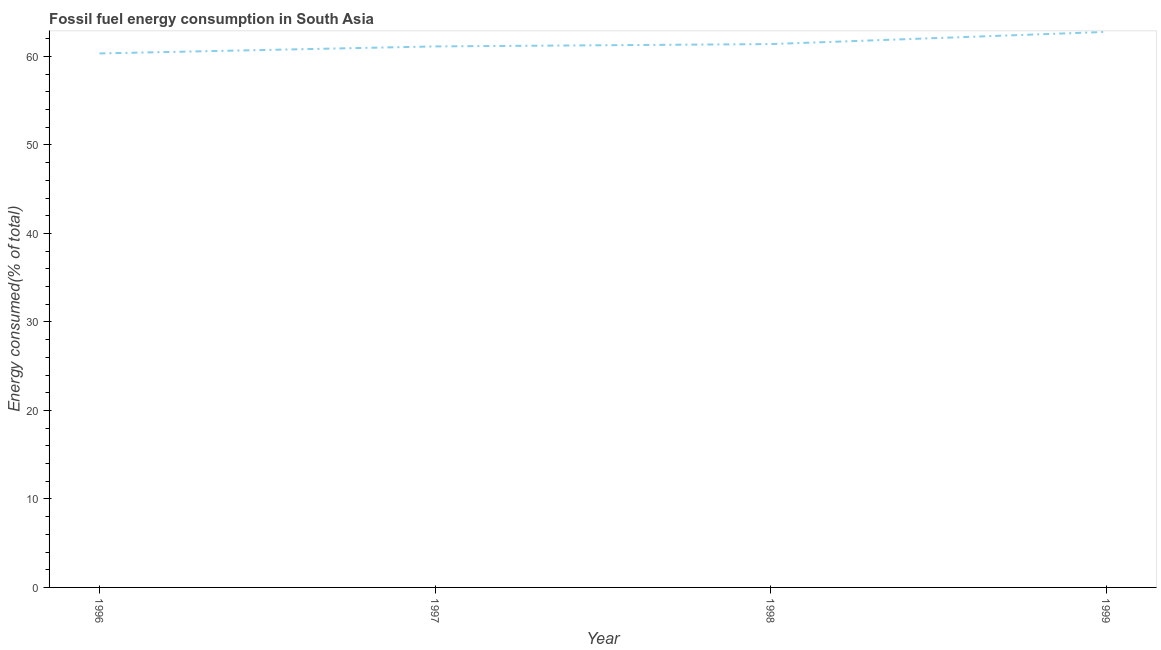What is the fossil fuel energy consumption in 1998?
Provide a succinct answer. 61.4. Across all years, what is the maximum fossil fuel energy consumption?
Give a very brief answer. 62.78. Across all years, what is the minimum fossil fuel energy consumption?
Make the answer very short. 60.34. In which year was the fossil fuel energy consumption minimum?
Give a very brief answer. 1996. What is the sum of the fossil fuel energy consumption?
Make the answer very short. 245.65. What is the difference between the fossil fuel energy consumption in 1996 and 1997?
Ensure brevity in your answer.  -0.79. What is the average fossil fuel energy consumption per year?
Provide a succinct answer. 61.41. What is the median fossil fuel energy consumption?
Make the answer very short. 61.27. In how many years, is the fossil fuel energy consumption greater than 4 %?
Offer a very short reply. 4. Do a majority of the years between 1998 and 1999 (inclusive) have fossil fuel energy consumption greater than 10 %?
Make the answer very short. Yes. What is the ratio of the fossil fuel energy consumption in 1996 to that in 1997?
Give a very brief answer. 0.99. Is the difference between the fossil fuel energy consumption in 1996 and 1997 greater than the difference between any two years?
Make the answer very short. No. What is the difference between the highest and the second highest fossil fuel energy consumption?
Keep it short and to the point. 1.38. Is the sum of the fossil fuel energy consumption in 1997 and 1998 greater than the maximum fossil fuel energy consumption across all years?
Your response must be concise. Yes. What is the difference between the highest and the lowest fossil fuel energy consumption?
Make the answer very short. 2.43. In how many years, is the fossil fuel energy consumption greater than the average fossil fuel energy consumption taken over all years?
Make the answer very short. 1. Does the fossil fuel energy consumption monotonically increase over the years?
Offer a terse response. Yes. How many lines are there?
Your answer should be very brief. 1. How many years are there in the graph?
Keep it short and to the point. 4. What is the difference between two consecutive major ticks on the Y-axis?
Offer a very short reply. 10. Does the graph contain grids?
Provide a short and direct response. No. What is the title of the graph?
Your answer should be very brief. Fossil fuel energy consumption in South Asia. What is the label or title of the Y-axis?
Keep it short and to the point. Energy consumed(% of total). What is the Energy consumed(% of total) of 1996?
Give a very brief answer. 60.34. What is the Energy consumed(% of total) in 1997?
Keep it short and to the point. 61.14. What is the Energy consumed(% of total) in 1998?
Your answer should be very brief. 61.4. What is the Energy consumed(% of total) of 1999?
Provide a short and direct response. 62.78. What is the difference between the Energy consumed(% of total) in 1996 and 1997?
Give a very brief answer. -0.79. What is the difference between the Energy consumed(% of total) in 1996 and 1998?
Your answer should be compact. -1.06. What is the difference between the Energy consumed(% of total) in 1996 and 1999?
Give a very brief answer. -2.43. What is the difference between the Energy consumed(% of total) in 1997 and 1998?
Ensure brevity in your answer.  -0.26. What is the difference between the Energy consumed(% of total) in 1997 and 1999?
Give a very brief answer. -1.64. What is the difference between the Energy consumed(% of total) in 1998 and 1999?
Your answer should be very brief. -1.38. What is the ratio of the Energy consumed(% of total) in 1996 to that in 1998?
Your response must be concise. 0.98. What is the ratio of the Energy consumed(% of total) in 1996 to that in 1999?
Your answer should be compact. 0.96. What is the ratio of the Energy consumed(% of total) in 1998 to that in 1999?
Offer a very short reply. 0.98. 